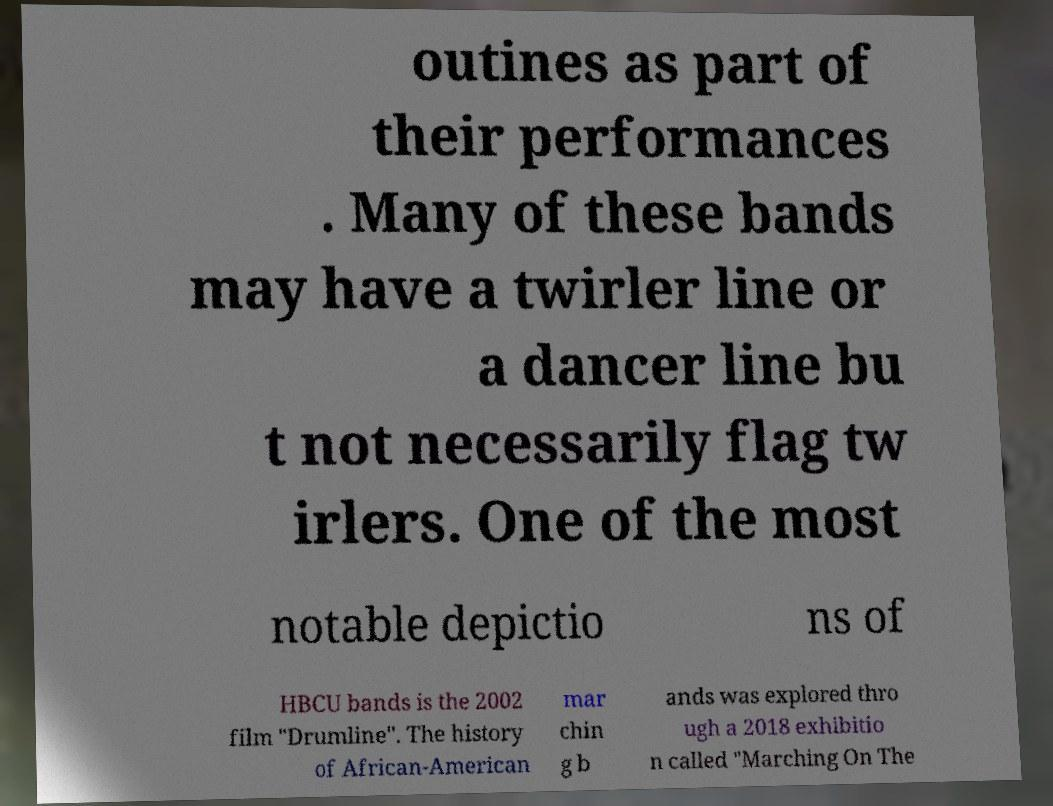I need the written content from this picture converted into text. Can you do that? outines as part of their performances . Many of these bands may have a twirler line or a dancer line bu t not necessarily flag tw irlers. One of the most notable depictio ns of HBCU bands is the 2002 film "Drumline". The history of African-American mar chin g b ands was explored thro ugh a 2018 exhibitio n called "Marching On The 